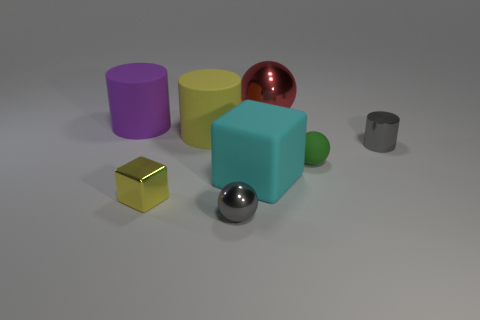Add 1 cyan metallic objects. How many objects exist? 9 Subtract all cubes. How many objects are left? 6 Add 1 small green balls. How many small green balls are left? 2 Add 6 large green rubber cubes. How many large green rubber cubes exist? 6 Subtract 0 blue cubes. How many objects are left? 8 Subtract all green metallic balls. Subtract all purple cylinders. How many objects are left? 7 